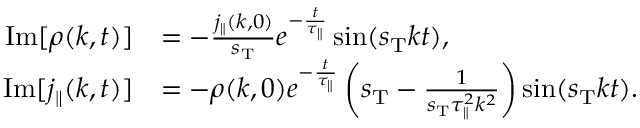<formula> <loc_0><loc_0><loc_500><loc_500>\begin{array} { r l } { I m [ \rho ( k , t ) ] } & { = - \frac { j _ { \| } ( k , 0 ) } { s _ { T } } e ^ { - \frac { t } { \tau _ { \| } } } \sin ( s _ { T } k t ) , } \\ { I m [ j _ { \| } ( k , t ) ] } & { = - \rho ( k , 0 ) e ^ { - \frac { t } { \tau _ { \| } } } \left ( s _ { T } - \frac { 1 } { s _ { T } \tau _ { \| } ^ { 2 } k ^ { 2 } } \right ) \sin ( s _ { T } k t ) . } \end{array}</formula> 